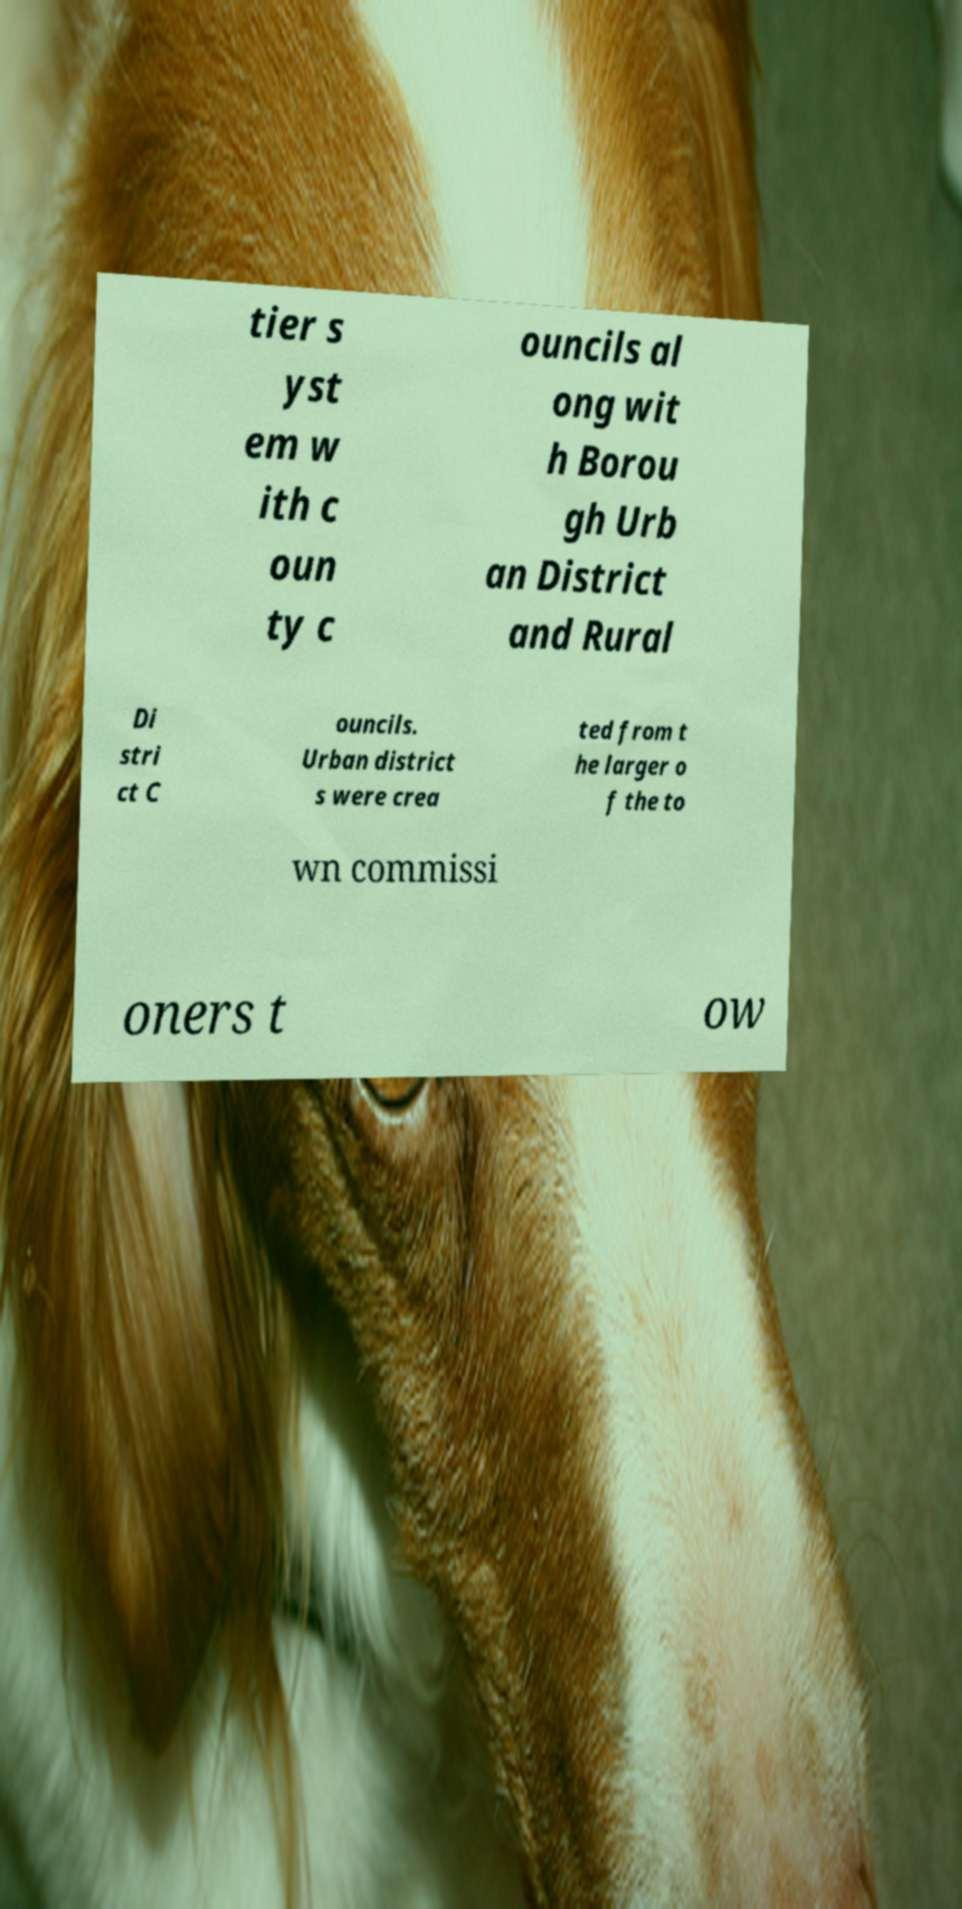Can you accurately transcribe the text from the provided image for me? tier s yst em w ith c oun ty c ouncils al ong wit h Borou gh Urb an District and Rural Di stri ct C ouncils. Urban district s were crea ted from t he larger o f the to wn commissi oners t ow 